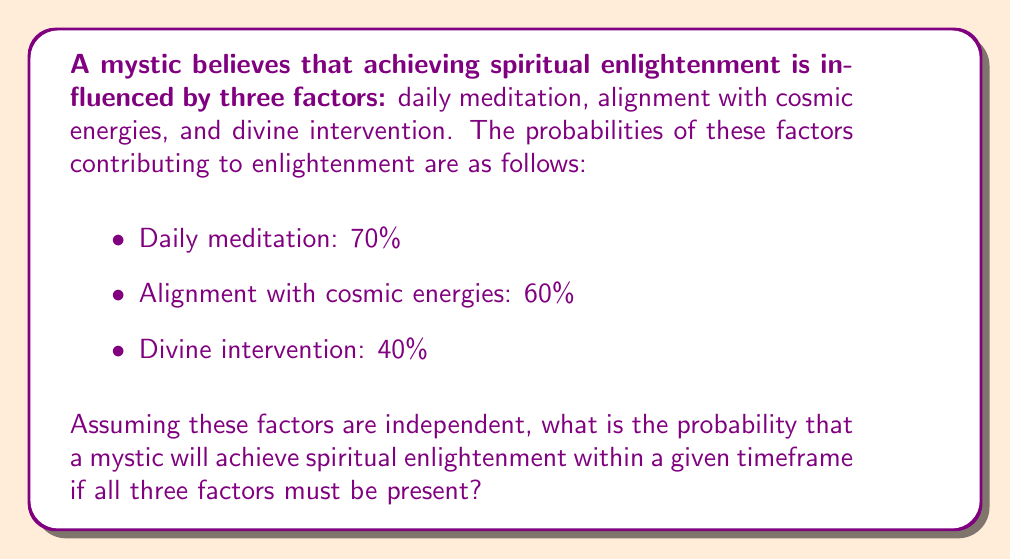Solve this math problem. To solve this problem, we need to use the concept of independent events in probability theory. For independent events, the probability of all events occurring simultaneously is the product of their individual probabilities.

Let's define our events:
$A$: Daily meditation contributes to enlightenment
$B$: Alignment with cosmic energies contributes to enlightenment
$C$: Divine intervention contributes to enlightenment

Given probabilities:
$P(A) = 0.70$
$P(B) = 0.60$
$P(C) = 0.40$

We want to find $P(A \cap B \cap C)$, the probability of all three events occurring together.

For independent events:

$$P(A \cap B \cap C) = P(A) \times P(B) \times P(C)$$

Substituting the given probabilities:

$$P(A \cap B \cap C) = 0.70 \times 0.60 \times 0.40$$

Calculating:

$$P(A \cap B \cap C) = 0.168$$

Therefore, the probability of achieving spiritual enlightenment within the given timeframe, assuming all three factors must be present, is 0.168 or 16.8%.
Answer: The probability of achieving spiritual enlightenment within the given timeframe is 0.168 or 16.8%. 